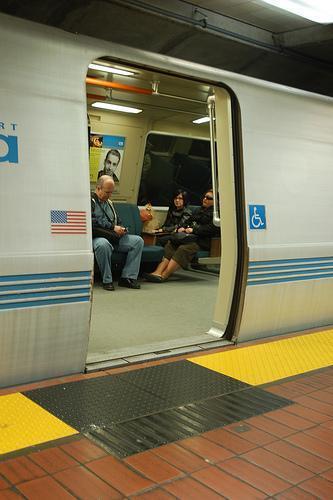How many people are in the picture?
Give a very brief answer. 3. 